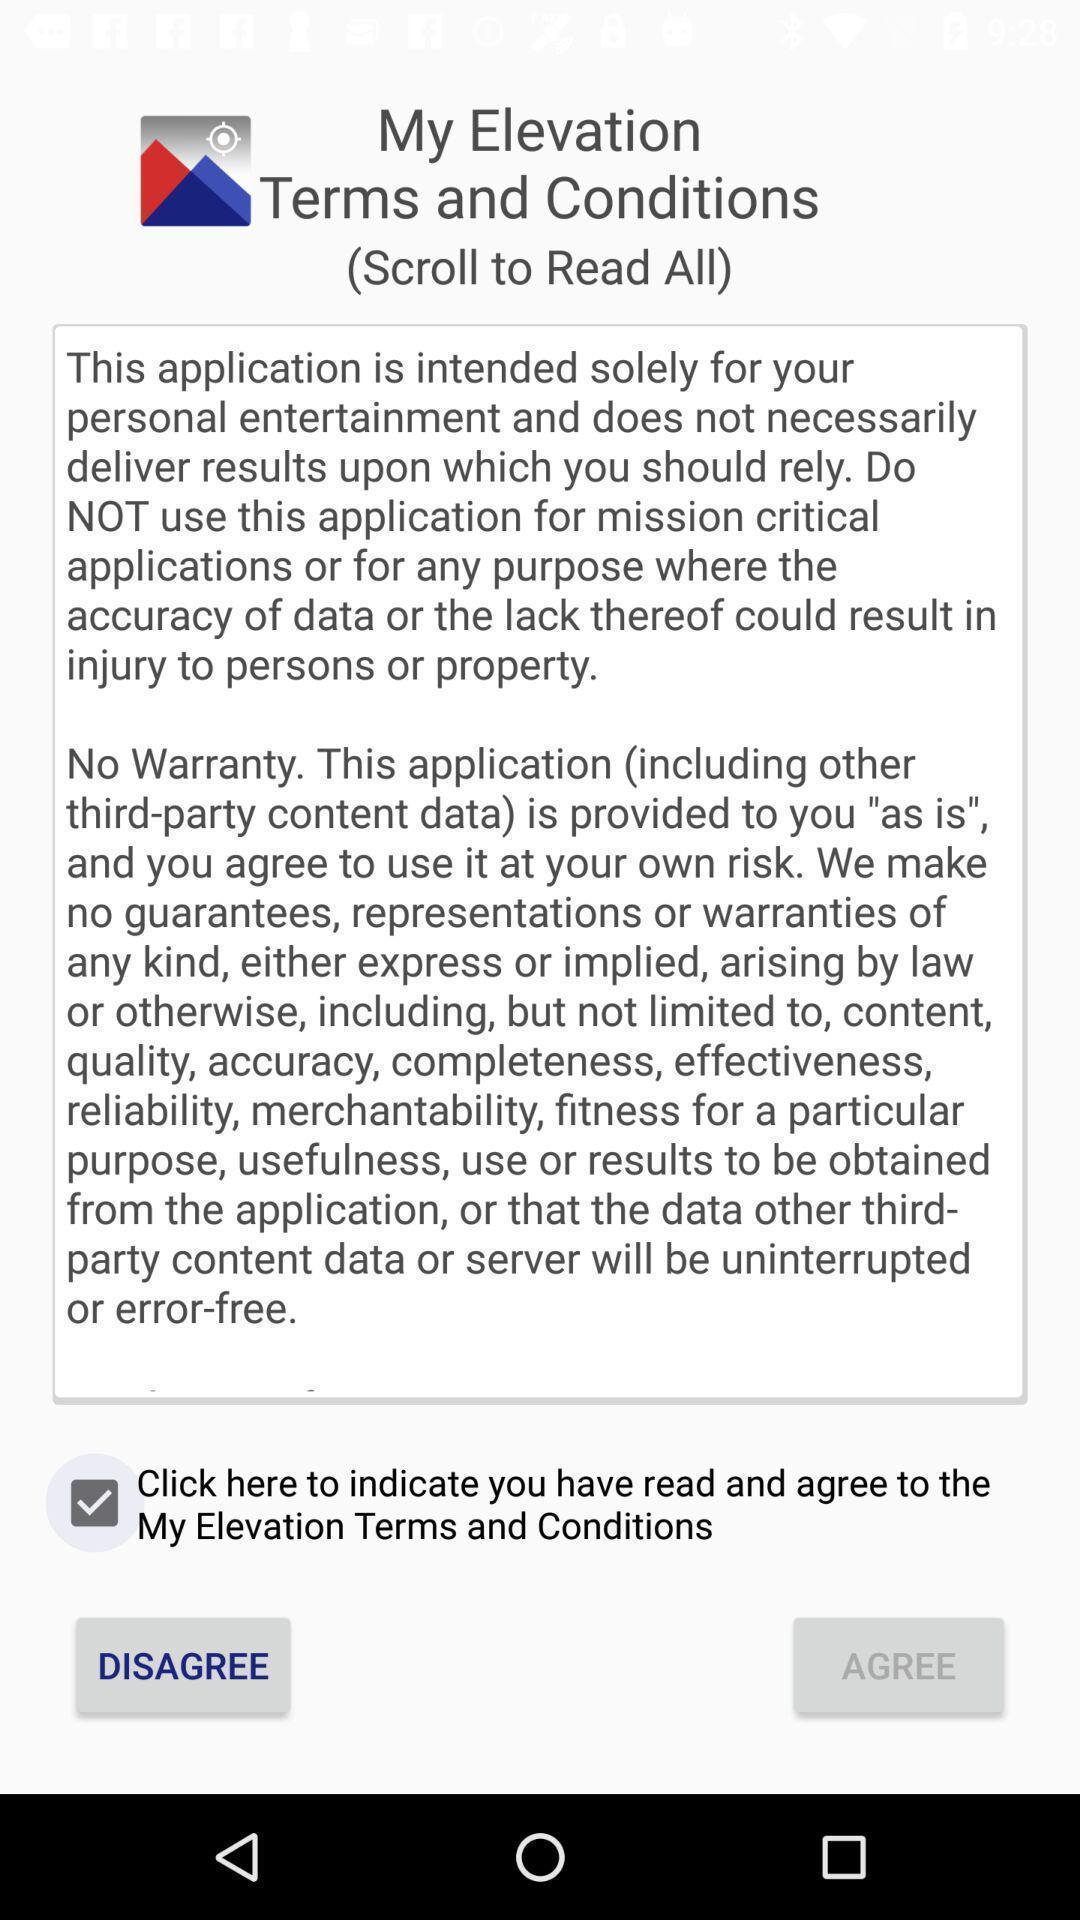What details can you identify in this image? Screen displaying terms and conditions. 